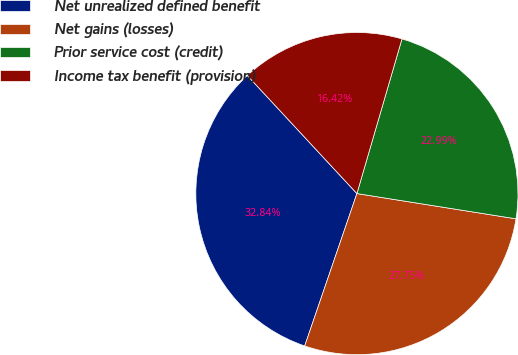Convert chart. <chart><loc_0><loc_0><loc_500><loc_500><pie_chart><fcel>Net unrealized defined benefit<fcel>Net gains (losses)<fcel>Prior service cost (credit)<fcel>Income tax benefit (provision)<nl><fcel>32.84%<fcel>27.75%<fcel>22.99%<fcel>16.42%<nl></chart> 